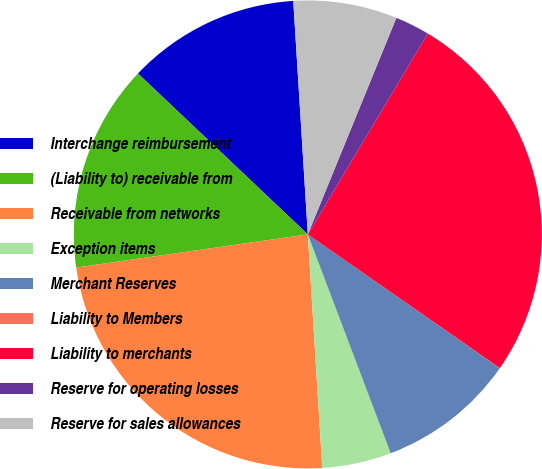Convert chart. <chart><loc_0><loc_0><loc_500><loc_500><pie_chart><fcel>Interchange reimbursement<fcel>(Liability to) receivable from<fcel>Receivable from networks<fcel>Exception items<fcel>Merchant Reserves<fcel>Liability to Members<fcel>Liability to merchants<fcel>Reserve for operating losses<fcel>Reserve for sales allowances<nl><fcel>11.94%<fcel>14.33%<fcel>23.72%<fcel>4.78%<fcel>9.55%<fcel>0.01%<fcel>26.11%<fcel>2.39%<fcel>7.17%<nl></chart> 